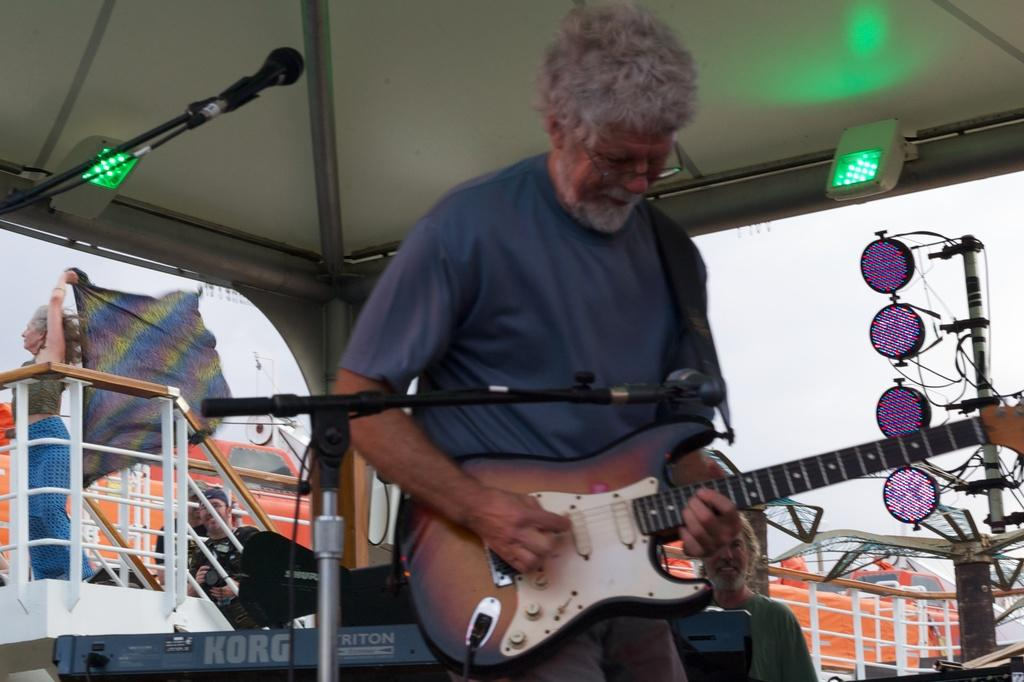What is the person in the image holding? The person is holding a guitar. What can be seen in the background of the image? There is a vehicle, a woman, a microphone, and a signal in the background of the image. How is the sky depicted in the image? The sky is cloudy in the image. What type of underwear is the person wearing in the image? There is no information about the person's underwear in the image, so it cannot be determined. 